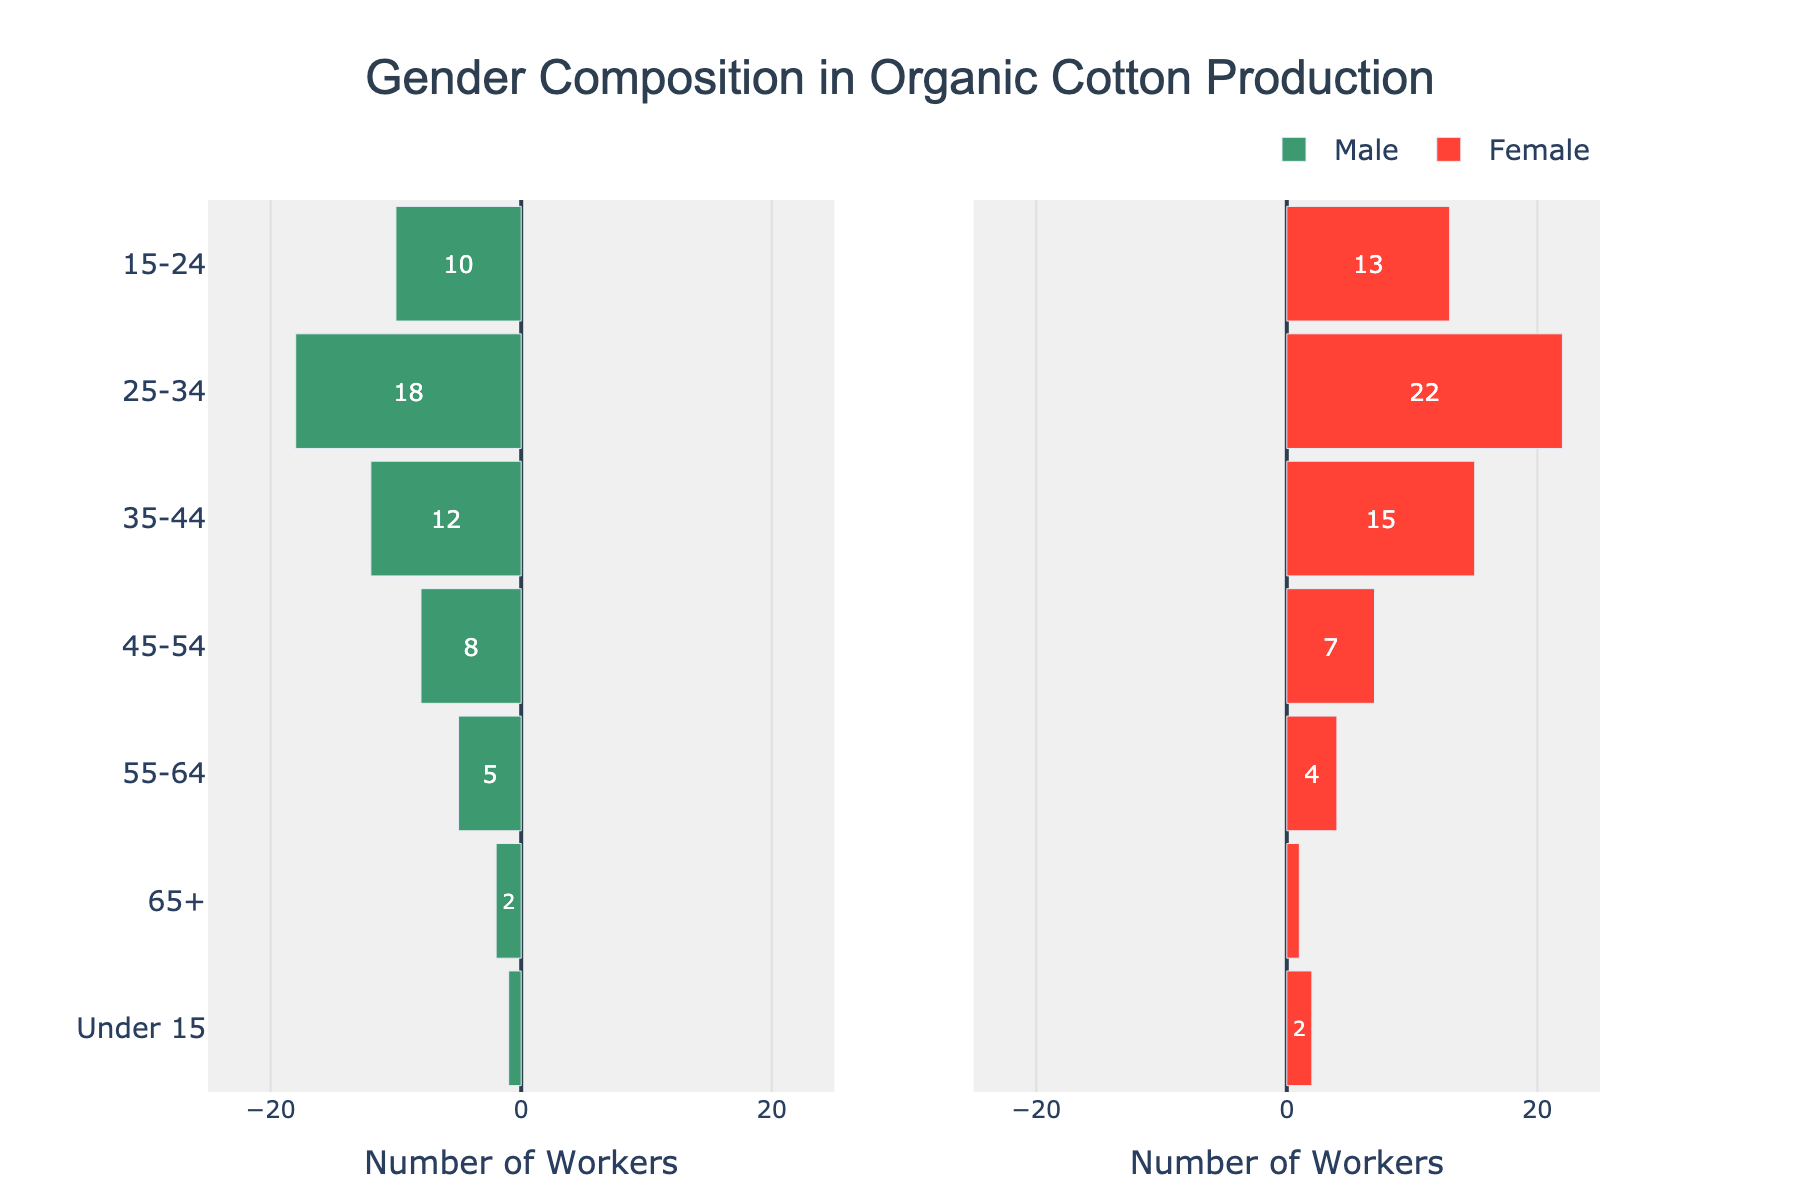What is the title of the figure? The title of the figure is located at the top center of the diagram and describes the overall subject of the visual data.
Answer: Gender Composition in Organic Cotton Production How many male workers are in the age group 15-24? To find the number of male workers in the 15-24 age group, look at the horizontal bar corresponding to '15-24'. The text inside the male bar shows the value.
Answer: 10 Which age group has the highest number of female workers? To find the age group with the highest number of female workers, compare the lengths of the female bars across all age groups. The longest one indicates the highest number.
Answer: 25-34 How many total workers are there in the age group 65+? Add the number of male workers and female workers in the 65+ age group to find the total workers. 2 males + 1 female = 3 workers.
Answer: 3 What is the difference in the number of workers between males and females in the age group 25-34? Subtract the number of male workers from the number of female workers in the 25-34 age group: 22 (female) - 18 (male) = 4.
Answer: 4 Are there more female or male workers in the age group 35-44? Compared the number of male and female workers in the age group 35-44 by looking at the values inside the bars.
Answer: Female In which age group is the gender composition of workers almost equal? Look for the age group where the difference between the lengths of the male and female bars is the smallest. The age group 45-54 has similar lengths for both genders.
Answer: 45-54 Which age group has the smallest number of total workers, and what is this total? Identify the smallest bars in both male and female categories and sum their values to find the total number of workers in that age group. The smallest bars are found in the under 15 category with 1 male + 2 females = 3 workers.
Answer: Under 15, 3 How does the number of male workers in the age group 55-64 compare to the number of female workers in the same group? Compare the length values of the bars for male and female workers in the age group 55-64. There are 5 male workers and 4 female workers, so there are more males.
Answer: Male workers are more What is the total number of workers in the age group 45-54? Add the number of male and female workers in the 45-54 age group. 8 males + 7 females = 15 workers.
Answer: 15 